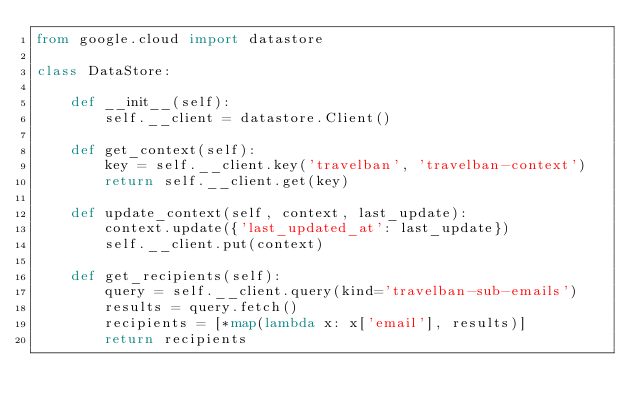Convert code to text. <code><loc_0><loc_0><loc_500><loc_500><_Python_>from google.cloud import datastore

class DataStore:

    def __init__(self):
        self.__client = datastore.Client()

    def get_context(self):
        key = self.__client.key('travelban', 'travelban-context')    
        return self.__client.get(key)

    def update_context(self, context, last_update):
        context.update({'last_updated_at': last_update})
        self.__client.put(context)

    def get_recipients(self):
        query = self.__client.query(kind='travelban-sub-emails')    
        results = query.fetch()
        recipients = [*map(lambda x: x['email'], results)]
        return recipients</code> 